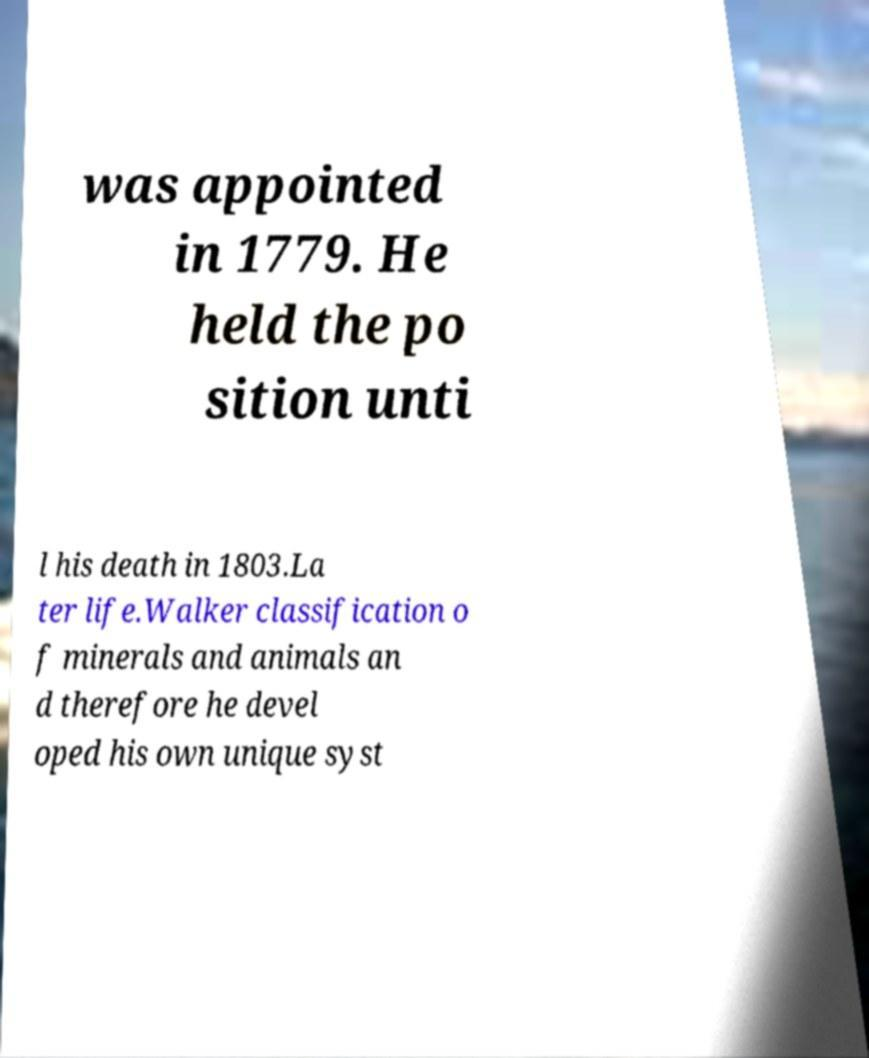Please read and relay the text visible in this image. What does it say? was appointed in 1779. He held the po sition unti l his death in 1803.La ter life.Walker classification o f minerals and animals an d therefore he devel oped his own unique syst 